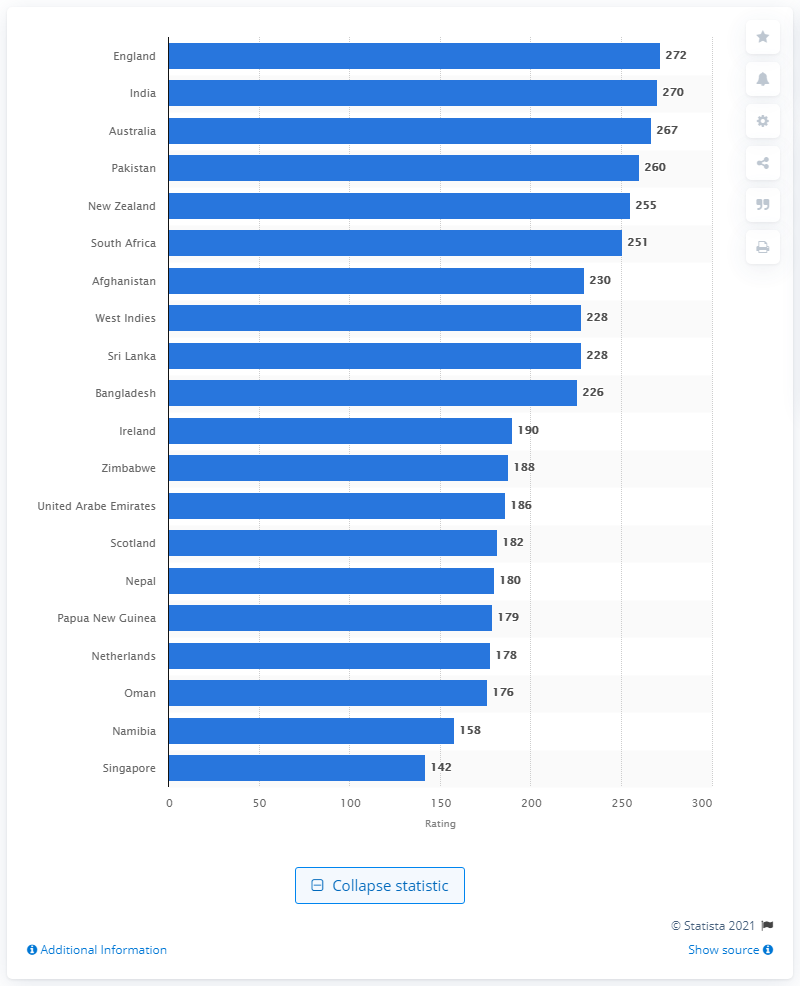Outline some significant characteristics in this image. England currently holds the top spot among men's T20 nations. According to the latest update in April 2021, England's rating for men's T20 nations is 272. 